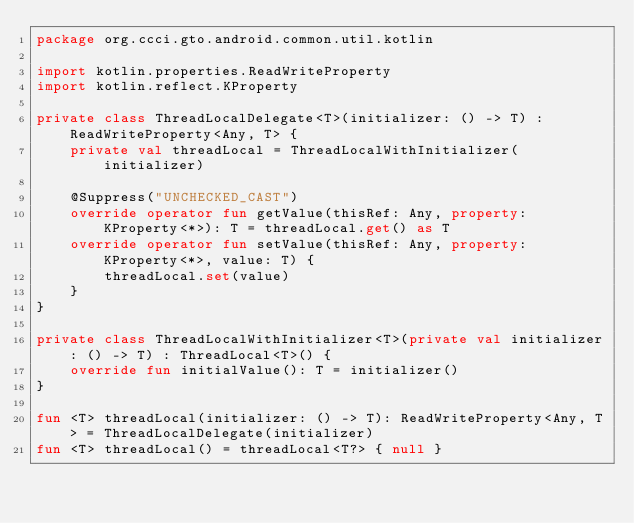<code> <loc_0><loc_0><loc_500><loc_500><_Kotlin_>package org.ccci.gto.android.common.util.kotlin

import kotlin.properties.ReadWriteProperty
import kotlin.reflect.KProperty

private class ThreadLocalDelegate<T>(initializer: () -> T) : ReadWriteProperty<Any, T> {
    private val threadLocal = ThreadLocalWithInitializer(initializer)

    @Suppress("UNCHECKED_CAST")
    override operator fun getValue(thisRef: Any, property: KProperty<*>): T = threadLocal.get() as T
    override operator fun setValue(thisRef: Any, property: KProperty<*>, value: T) {
        threadLocal.set(value)
    }
}

private class ThreadLocalWithInitializer<T>(private val initializer: () -> T) : ThreadLocal<T>() {
    override fun initialValue(): T = initializer()
}

fun <T> threadLocal(initializer: () -> T): ReadWriteProperty<Any, T> = ThreadLocalDelegate(initializer)
fun <T> threadLocal() = threadLocal<T?> { null }
</code> 